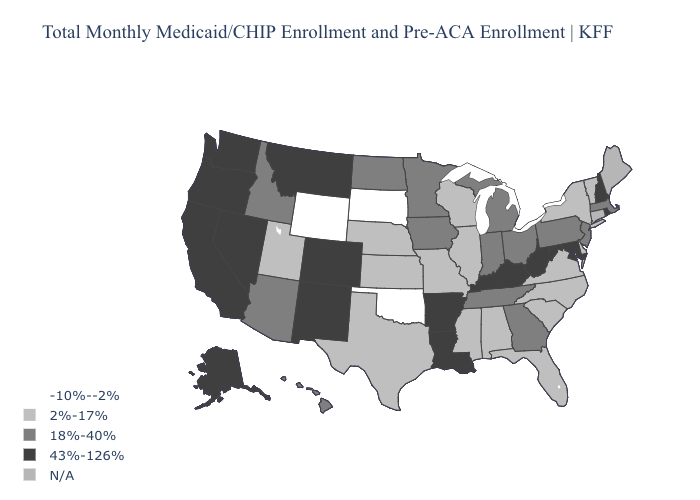Name the states that have a value in the range 43%-126%?
Concise answer only. Alaska, Arkansas, California, Colorado, Kentucky, Louisiana, Maryland, Montana, Nevada, New Hampshire, New Mexico, Oregon, Rhode Island, Washington, West Virginia. What is the value of Oklahoma?
Answer briefly. -10%--2%. What is the lowest value in the South?
Short answer required. -10%--2%. What is the value of Wyoming?
Keep it brief. -10%--2%. Name the states that have a value in the range 43%-126%?
Answer briefly. Alaska, Arkansas, California, Colorado, Kentucky, Louisiana, Maryland, Montana, Nevada, New Hampshire, New Mexico, Oregon, Rhode Island, Washington, West Virginia. What is the value of Louisiana?
Short answer required. 43%-126%. Name the states that have a value in the range 43%-126%?
Write a very short answer. Alaska, Arkansas, California, Colorado, Kentucky, Louisiana, Maryland, Montana, Nevada, New Hampshire, New Mexico, Oregon, Rhode Island, Washington, West Virginia. Name the states that have a value in the range N/A?
Be succinct. Connecticut, Maine. Name the states that have a value in the range -10%--2%?
Be succinct. Oklahoma, South Dakota, Wyoming. Among the states that border Utah , does Wyoming have the lowest value?
Answer briefly. Yes. Does the first symbol in the legend represent the smallest category?
Concise answer only. Yes. Name the states that have a value in the range N/A?
Short answer required. Connecticut, Maine. Which states have the highest value in the USA?
Answer briefly. Alaska, Arkansas, California, Colorado, Kentucky, Louisiana, Maryland, Montana, Nevada, New Hampshire, New Mexico, Oregon, Rhode Island, Washington, West Virginia. 